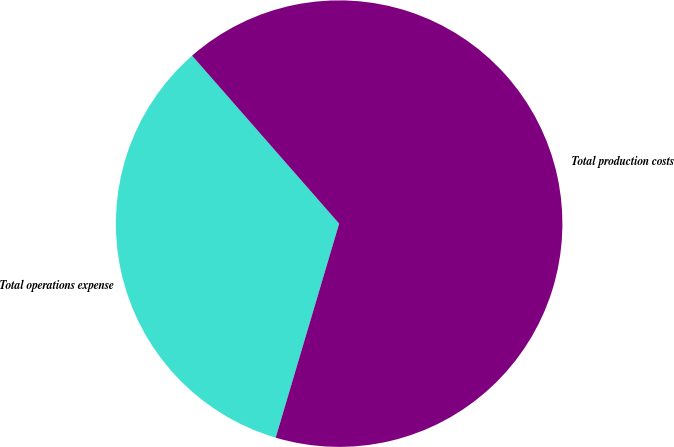<chart> <loc_0><loc_0><loc_500><loc_500><pie_chart><fcel>Total operations expense<fcel>Total production costs<nl><fcel>33.97%<fcel>66.03%<nl></chart> 